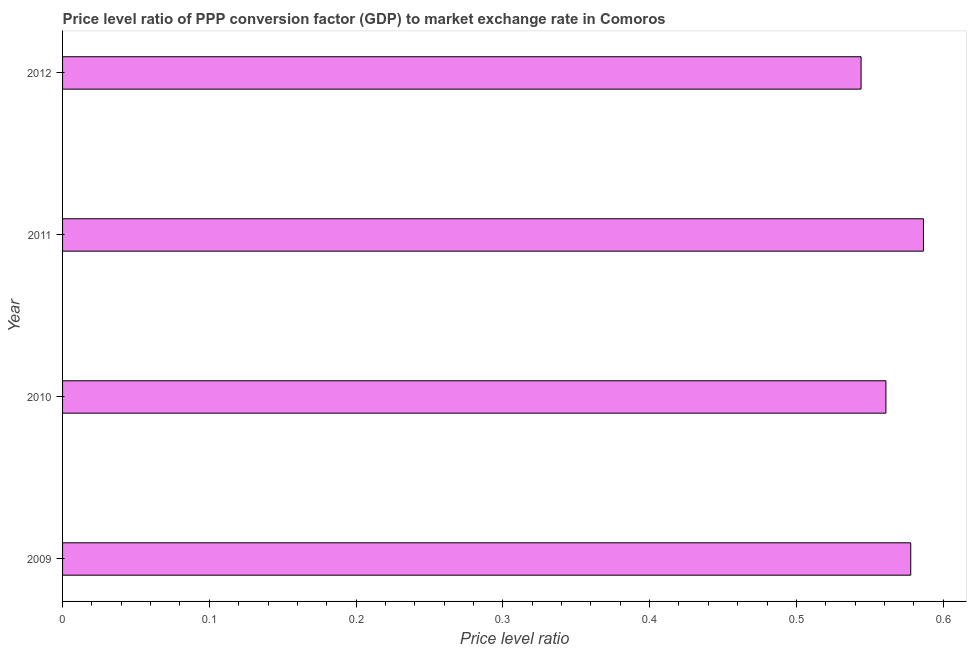Does the graph contain any zero values?
Make the answer very short. No. What is the title of the graph?
Provide a short and direct response. Price level ratio of PPP conversion factor (GDP) to market exchange rate in Comoros. What is the label or title of the X-axis?
Make the answer very short. Price level ratio. What is the label or title of the Y-axis?
Your response must be concise. Year. What is the price level ratio in 2011?
Offer a terse response. 0.59. Across all years, what is the maximum price level ratio?
Provide a short and direct response. 0.59. Across all years, what is the minimum price level ratio?
Offer a very short reply. 0.54. In which year was the price level ratio maximum?
Your response must be concise. 2011. What is the sum of the price level ratio?
Ensure brevity in your answer.  2.27. What is the difference between the price level ratio in 2009 and 2011?
Provide a succinct answer. -0.01. What is the average price level ratio per year?
Ensure brevity in your answer.  0.57. What is the median price level ratio?
Your answer should be compact. 0.57. In how many years, is the price level ratio greater than 0.14 ?
Offer a very short reply. 4. What is the ratio of the price level ratio in 2010 to that in 2012?
Your answer should be very brief. 1.03. Is the price level ratio in 2011 less than that in 2012?
Ensure brevity in your answer.  No. What is the difference between the highest and the second highest price level ratio?
Ensure brevity in your answer.  0.01. Is the sum of the price level ratio in 2011 and 2012 greater than the maximum price level ratio across all years?
Make the answer very short. Yes. What is the difference between the highest and the lowest price level ratio?
Provide a short and direct response. 0.04. In how many years, is the price level ratio greater than the average price level ratio taken over all years?
Your answer should be very brief. 2. Are all the bars in the graph horizontal?
Your answer should be compact. Yes. How many years are there in the graph?
Your answer should be compact. 4. What is the difference between two consecutive major ticks on the X-axis?
Keep it short and to the point. 0.1. What is the Price level ratio of 2009?
Make the answer very short. 0.58. What is the Price level ratio in 2010?
Ensure brevity in your answer.  0.56. What is the Price level ratio in 2011?
Offer a terse response. 0.59. What is the Price level ratio of 2012?
Keep it short and to the point. 0.54. What is the difference between the Price level ratio in 2009 and 2010?
Keep it short and to the point. 0.02. What is the difference between the Price level ratio in 2009 and 2011?
Offer a very short reply. -0.01. What is the difference between the Price level ratio in 2009 and 2012?
Keep it short and to the point. 0.03. What is the difference between the Price level ratio in 2010 and 2011?
Offer a terse response. -0.03. What is the difference between the Price level ratio in 2010 and 2012?
Ensure brevity in your answer.  0.02. What is the difference between the Price level ratio in 2011 and 2012?
Provide a short and direct response. 0.04. What is the ratio of the Price level ratio in 2009 to that in 2011?
Keep it short and to the point. 0.98. What is the ratio of the Price level ratio in 2009 to that in 2012?
Provide a succinct answer. 1.06. What is the ratio of the Price level ratio in 2010 to that in 2011?
Keep it short and to the point. 0.96. What is the ratio of the Price level ratio in 2010 to that in 2012?
Keep it short and to the point. 1.03. What is the ratio of the Price level ratio in 2011 to that in 2012?
Your response must be concise. 1.08. 